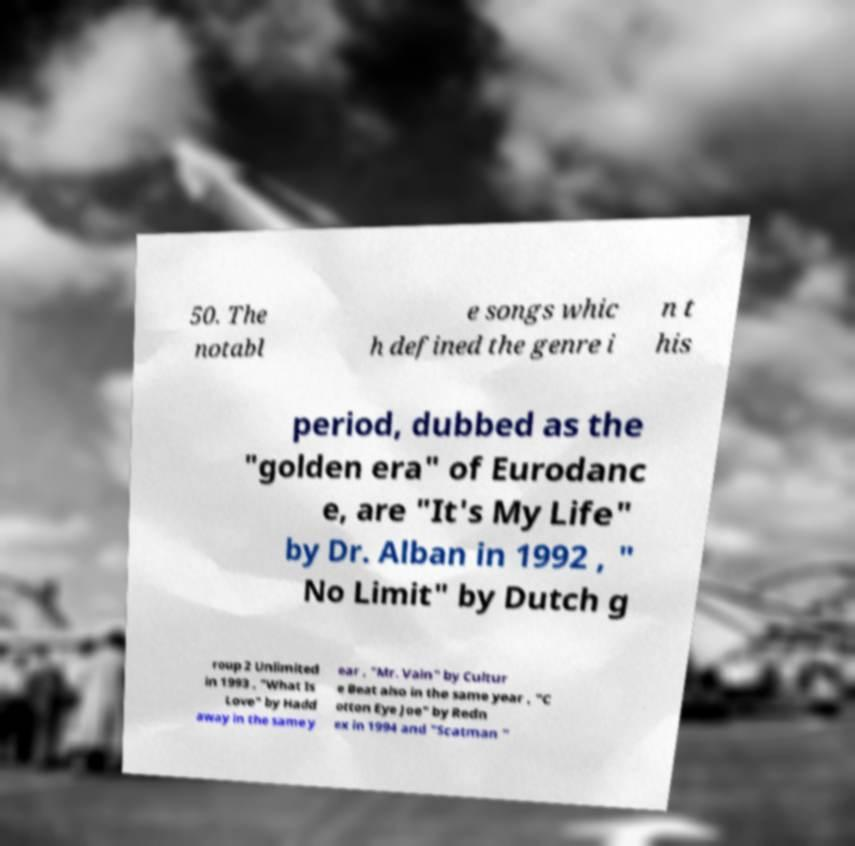Please read and relay the text visible in this image. What does it say? 50. The notabl e songs whic h defined the genre i n t his period, dubbed as the "golden era" of Eurodanc e, are "It's My Life" by Dr. Alban in 1992 , " No Limit" by Dutch g roup 2 Unlimited in 1993 , "What Is Love" by Hadd away in the same y ear , "Mr. Vain" by Cultur e Beat also in the same year , "C otton Eye Joe" by Redn ex in 1994 and "Scatman " 